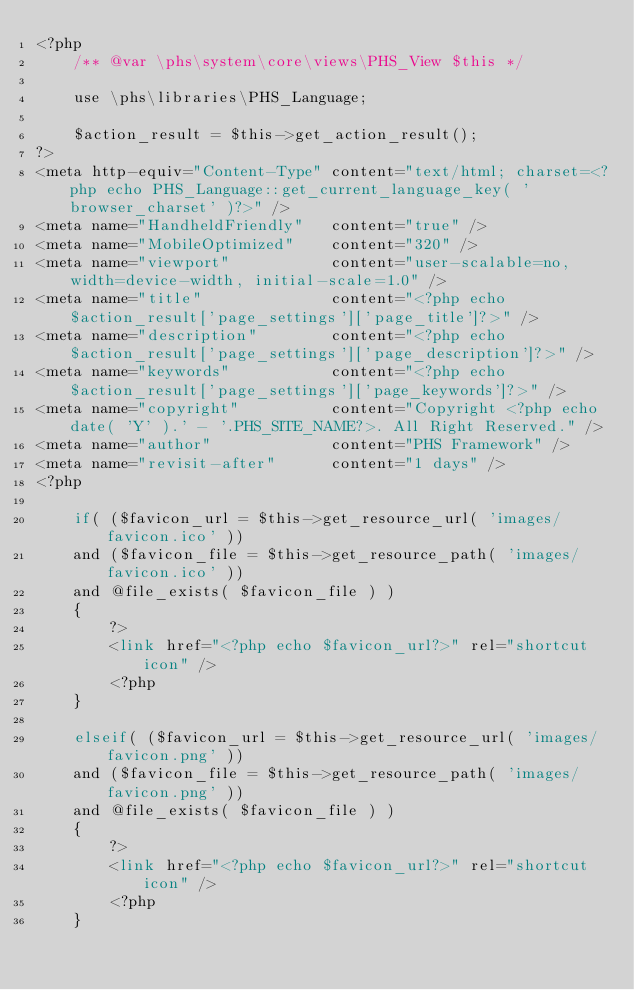<code> <loc_0><loc_0><loc_500><loc_500><_PHP_><?php
    /** @var \phs\system\core\views\PHS_View $this */

    use \phs\libraries\PHS_Language;

    $action_result = $this->get_action_result();
?>
<meta http-equiv="Content-Type" content="text/html; charset=<?php echo PHS_Language::get_current_language_key( 'browser_charset' )?>" />
<meta name="HandheldFriendly"   content="true" />
<meta name="MobileOptimized"    content="320" />
<meta name="viewport"           content="user-scalable=no, width=device-width, initial-scale=1.0" />
<meta name="title"              content="<?php echo $action_result['page_settings']['page_title']?>" />
<meta name="description"        content="<?php echo $action_result['page_settings']['page_description']?>" />
<meta name="keywords"           content="<?php echo $action_result['page_settings']['page_keywords']?>" />
<meta name="copyright"          content="Copyright <?php echo date( 'Y' ).' - '.PHS_SITE_NAME?>. All Right Reserved." />
<meta name="author"             content="PHS Framework" />
<meta name="revisit-after"      content="1 days" />
<?php

    if( ($favicon_url = $this->get_resource_url( 'images/favicon.ico' ))
    and ($favicon_file = $this->get_resource_path( 'images/favicon.ico' ))
    and @file_exists( $favicon_file ) )
    {
        ?>
        <link href="<?php echo $favicon_url?>" rel="shortcut icon" />
        <?php
    }

    elseif( ($favicon_url = $this->get_resource_url( 'images/favicon.png' ))
    and ($favicon_file = $this->get_resource_path( 'images/favicon.png' ))
    and @file_exists( $favicon_file ) )
    {
        ?>
        <link href="<?php echo $favicon_url?>" rel="shortcut icon" />
        <?php
    }
</code> 